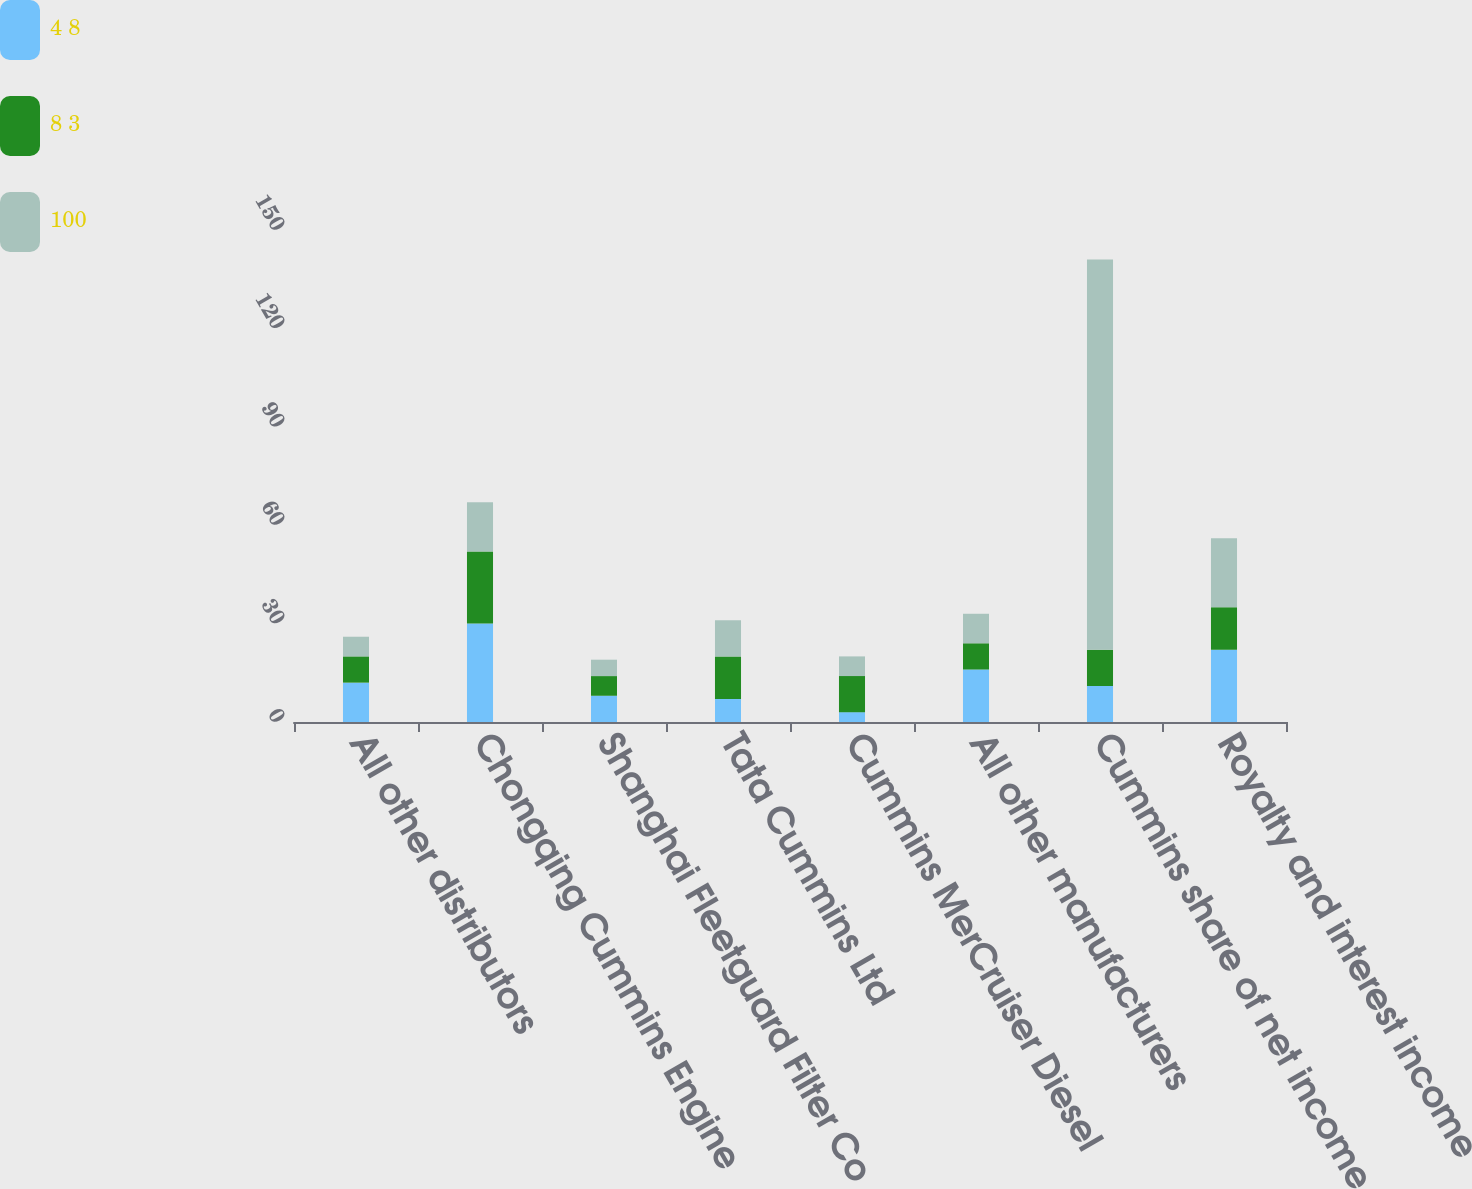Convert chart. <chart><loc_0><loc_0><loc_500><loc_500><stacked_bar_chart><ecel><fcel>All other distributors<fcel>Chongqing Cummins Engine<fcel>Shanghai Fleetguard Filter Co<fcel>Tata Cummins Ltd<fcel>Cummins MerCruiser Diesel<fcel>All other manufacturers<fcel>Cummins share of net income<fcel>Royalty and interest income<nl><fcel>4 8<fcel>12<fcel>30<fcel>8<fcel>7<fcel>3<fcel>16<fcel>11<fcel>22<nl><fcel>8 3<fcel>8<fcel>22<fcel>6<fcel>13<fcel>11<fcel>8<fcel>11<fcel>13<nl><fcel>100<fcel>6<fcel>15<fcel>5<fcel>11<fcel>6<fcel>9<fcel>119<fcel>21<nl></chart> 